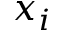Convert formula to latex. <formula><loc_0><loc_0><loc_500><loc_500>x _ { i }</formula> 